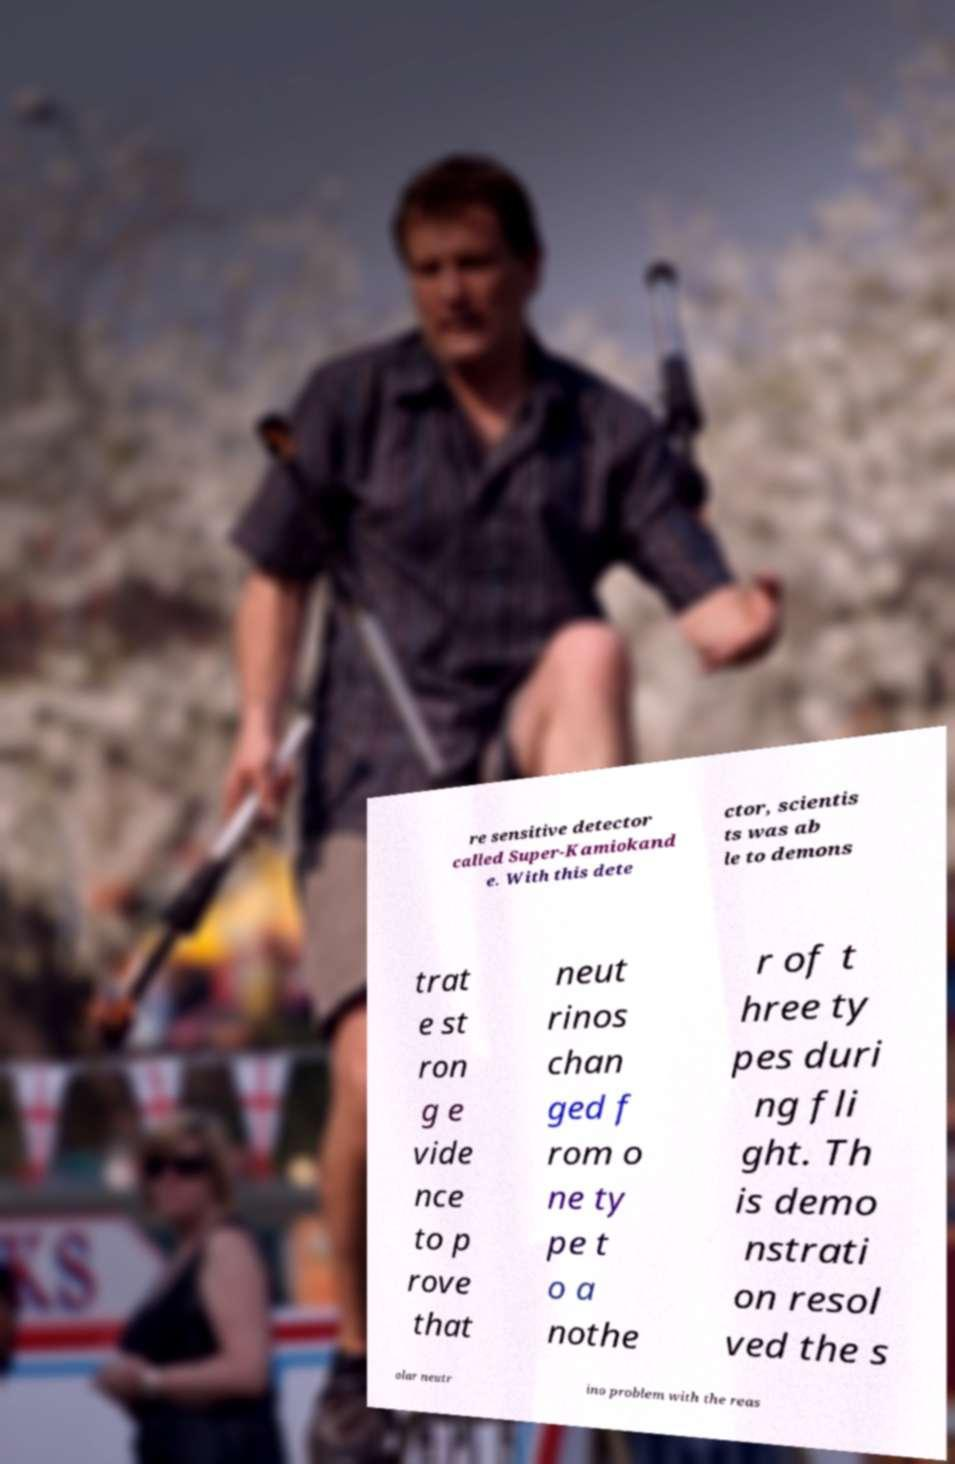I need the written content from this picture converted into text. Can you do that? re sensitive detector called Super-Kamiokand e. With this dete ctor, scientis ts was ab le to demons trat e st ron g e vide nce to p rove that neut rinos chan ged f rom o ne ty pe t o a nothe r of t hree ty pes duri ng fli ght. Th is demo nstrati on resol ved the s olar neutr ino problem with the reas 